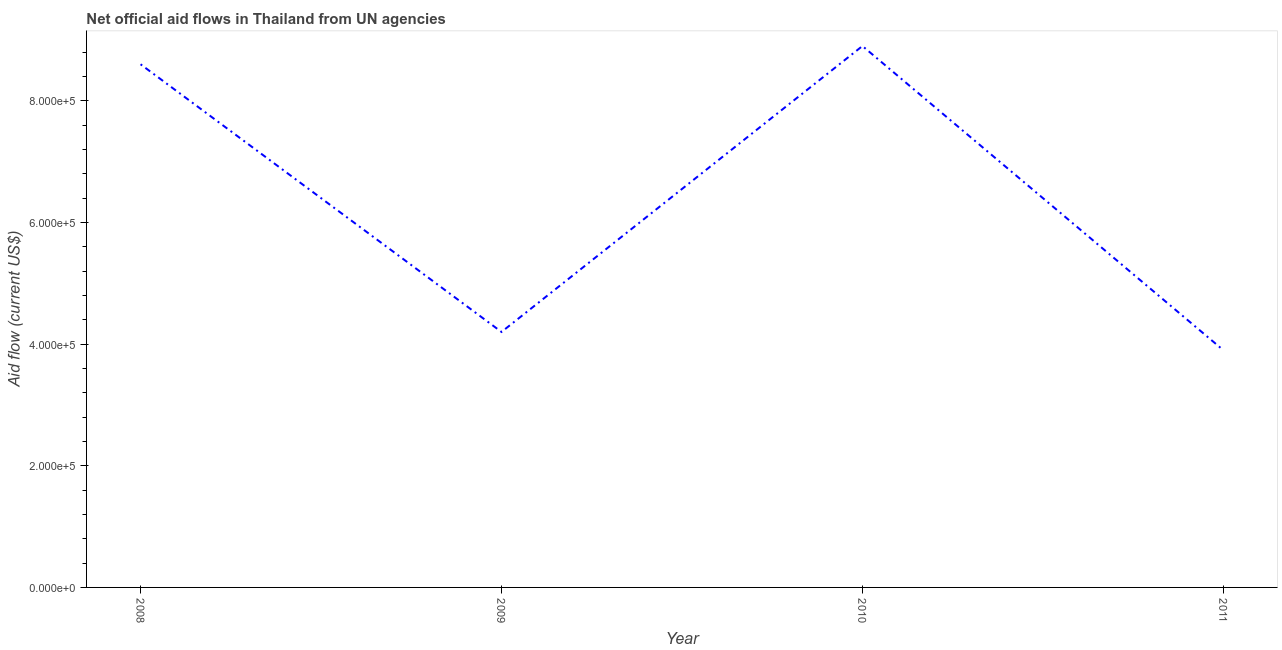What is the net official flows from un agencies in 2010?
Make the answer very short. 8.90e+05. Across all years, what is the maximum net official flows from un agencies?
Provide a short and direct response. 8.90e+05. Across all years, what is the minimum net official flows from un agencies?
Offer a terse response. 3.90e+05. In which year was the net official flows from un agencies minimum?
Ensure brevity in your answer.  2011. What is the sum of the net official flows from un agencies?
Provide a short and direct response. 2.56e+06. What is the difference between the net official flows from un agencies in 2008 and 2009?
Offer a very short reply. 4.40e+05. What is the average net official flows from un agencies per year?
Your answer should be very brief. 6.40e+05. What is the median net official flows from un agencies?
Keep it short and to the point. 6.40e+05. In how many years, is the net official flows from un agencies greater than 160000 US$?
Give a very brief answer. 4. What is the ratio of the net official flows from un agencies in 2009 to that in 2010?
Give a very brief answer. 0.47. Is the net official flows from un agencies in 2009 less than that in 2010?
Your response must be concise. Yes. Is the difference between the net official flows from un agencies in 2008 and 2011 greater than the difference between any two years?
Provide a short and direct response. No. What is the difference between the highest and the second highest net official flows from un agencies?
Make the answer very short. 3.00e+04. What is the difference between the highest and the lowest net official flows from un agencies?
Keep it short and to the point. 5.00e+05. In how many years, is the net official flows from un agencies greater than the average net official flows from un agencies taken over all years?
Offer a very short reply. 2. Does the net official flows from un agencies monotonically increase over the years?
Give a very brief answer. No. How many years are there in the graph?
Your answer should be compact. 4. What is the difference between two consecutive major ticks on the Y-axis?
Offer a very short reply. 2.00e+05. Does the graph contain any zero values?
Offer a very short reply. No. Does the graph contain grids?
Offer a very short reply. No. What is the title of the graph?
Your answer should be compact. Net official aid flows in Thailand from UN agencies. What is the label or title of the Y-axis?
Make the answer very short. Aid flow (current US$). What is the Aid flow (current US$) of 2008?
Provide a short and direct response. 8.60e+05. What is the Aid flow (current US$) in 2010?
Provide a short and direct response. 8.90e+05. What is the difference between the Aid flow (current US$) in 2008 and 2009?
Your response must be concise. 4.40e+05. What is the difference between the Aid flow (current US$) in 2009 and 2010?
Your answer should be compact. -4.70e+05. What is the difference between the Aid flow (current US$) in 2009 and 2011?
Provide a short and direct response. 3.00e+04. What is the ratio of the Aid flow (current US$) in 2008 to that in 2009?
Keep it short and to the point. 2.05. What is the ratio of the Aid flow (current US$) in 2008 to that in 2010?
Provide a succinct answer. 0.97. What is the ratio of the Aid flow (current US$) in 2008 to that in 2011?
Your response must be concise. 2.21. What is the ratio of the Aid flow (current US$) in 2009 to that in 2010?
Offer a terse response. 0.47. What is the ratio of the Aid flow (current US$) in 2009 to that in 2011?
Make the answer very short. 1.08. What is the ratio of the Aid flow (current US$) in 2010 to that in 2011?
Your answer should be very brief. 2.28. 